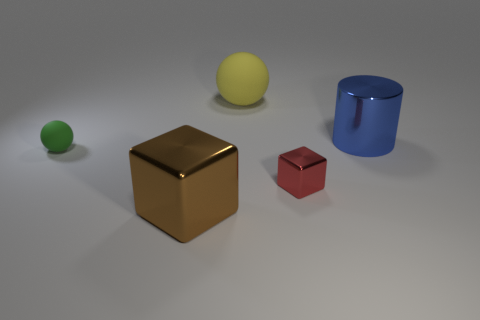Is the block that is right of the brown shiny cube made of the same material as the yellow ball?
Provide a short and direct response. No. How many other objects are the same material as the big yellow ball?
Give a very brief answer. 1. What number of objects are either cubes that are in front of the small red metallic cube or shiny things to the right of the brown cube?
Your response must be concise. 3. There is a object right of the red object; does it have the same shape as the small green rubber thing that is left of the yellow object?
Your answer should be very brief. No. There is a yellow thing that is the same size as the blue object; what is its shape?
Make the answer very short. Sphere. What number of matte objects are either blue balls or green spheres?
Make the answer very short. 1. Do the block left of the small shiny object and the ball behind the big blue cylinder have the same material?
Keep it short and to the point. No. What color is the other large block that is the same material as the red block?
Keep it short and to the point. Brown. Is the number of blue things that are to the left of the large brown object greater than the number of big yellow rubber objects on the right side of the big blue metallic cylinder?
Provide a short and direct response. No. Are any large purple cubes visible?
Offer a very short reply. No. 